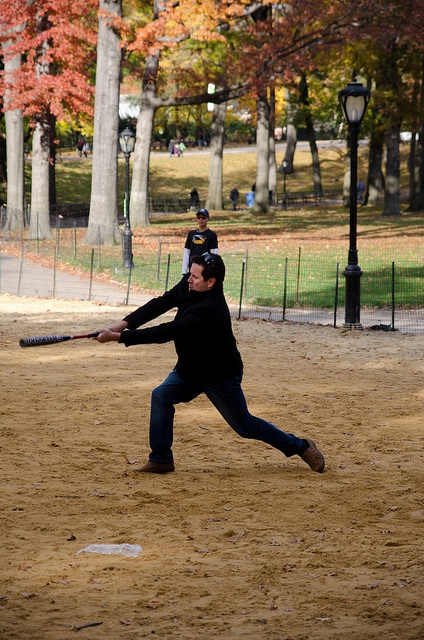Describe the objects in this image and their specific colors. I can see people in darkgray, black, gray, tan, and maroon tones, people in darkgray, black, gray, and maroon tones, bench in darkgray, black, and gray tones, bench in darkgray, black, and gray tones, and baseball bat in darkgray, black, and gray tones in this image. 